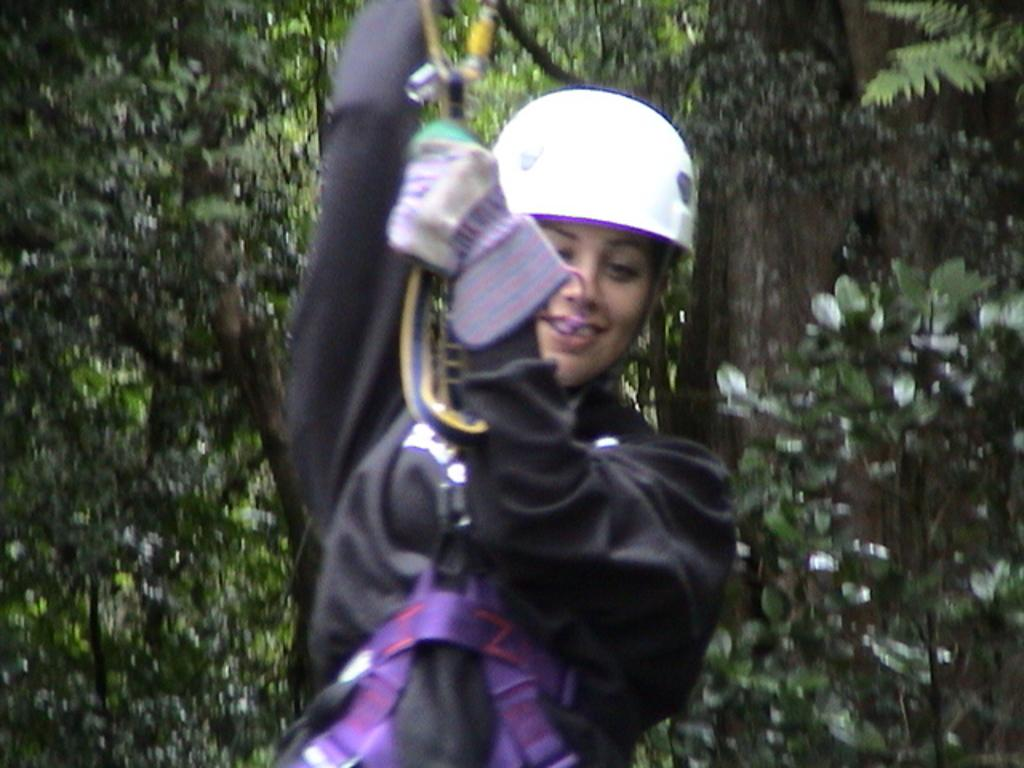Who is present in the image? There is a woman in the image. What is the woman holding in the image? The woman is holding a rope. What is the woman doing in the image? The woman is hanging. What protective gear is the woman wearing in the image? The woman is wearing a helmet. What type of clothing is the woman wearing in the image? The woman is wearing a jerkin. What type of vegetation can be seen in the image? There are trees with branches and leaves in the image. What letter does the woman receive in the image? There is no letter present in the image. 